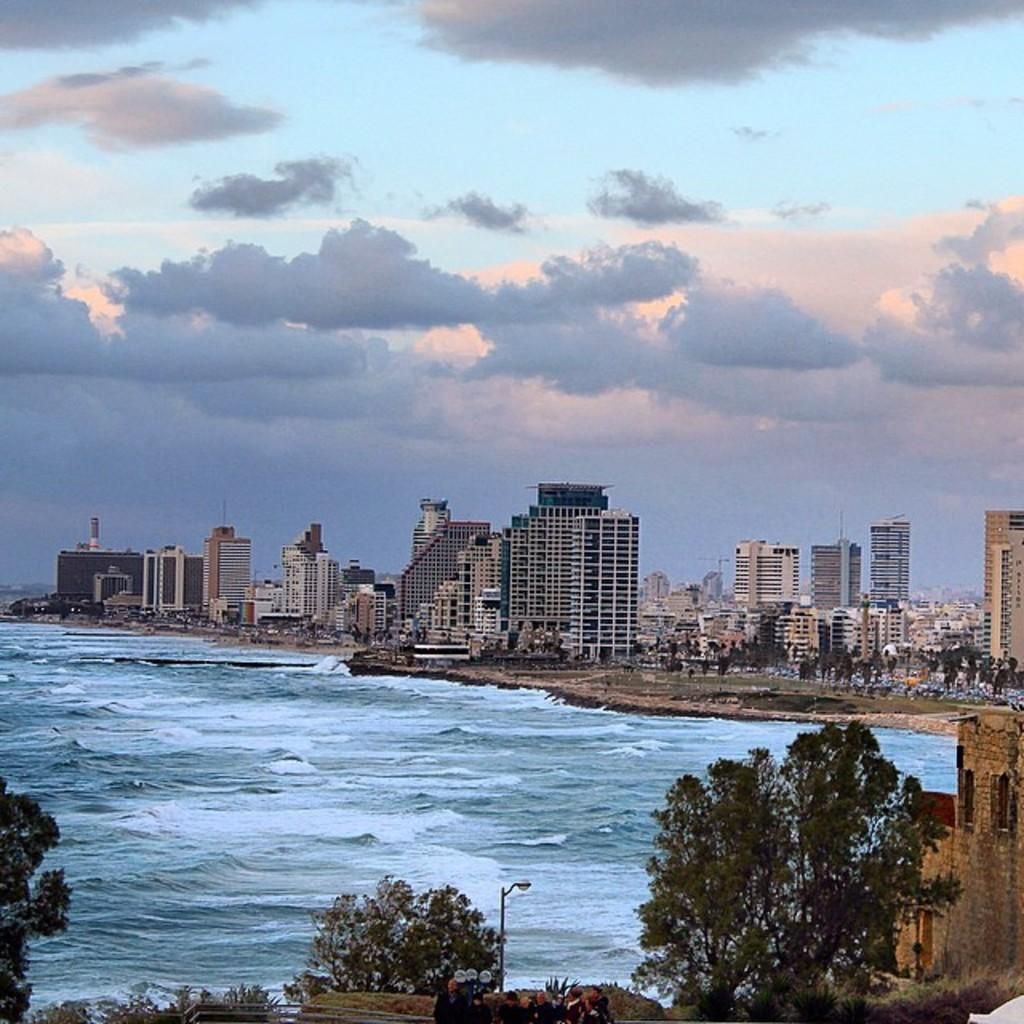What type of structures can be seen in the image? There are buildings in the image. What natural element is visible in the image? There is water visible in the image. What type of vegetation is present in the image? There are trees in the image. What can be seen in the background of the image? The sky is visible in the background of the image. What type of man-made object is present in the image? There is a street light in the image. Can you see any feathers floating in the water in the image? There are no feathers visible in the image. What type of grape is being used to draw attention to the buildings in the image? There is no grape present in the image, and the buildings do not require any additional attention-grabbing elements. 